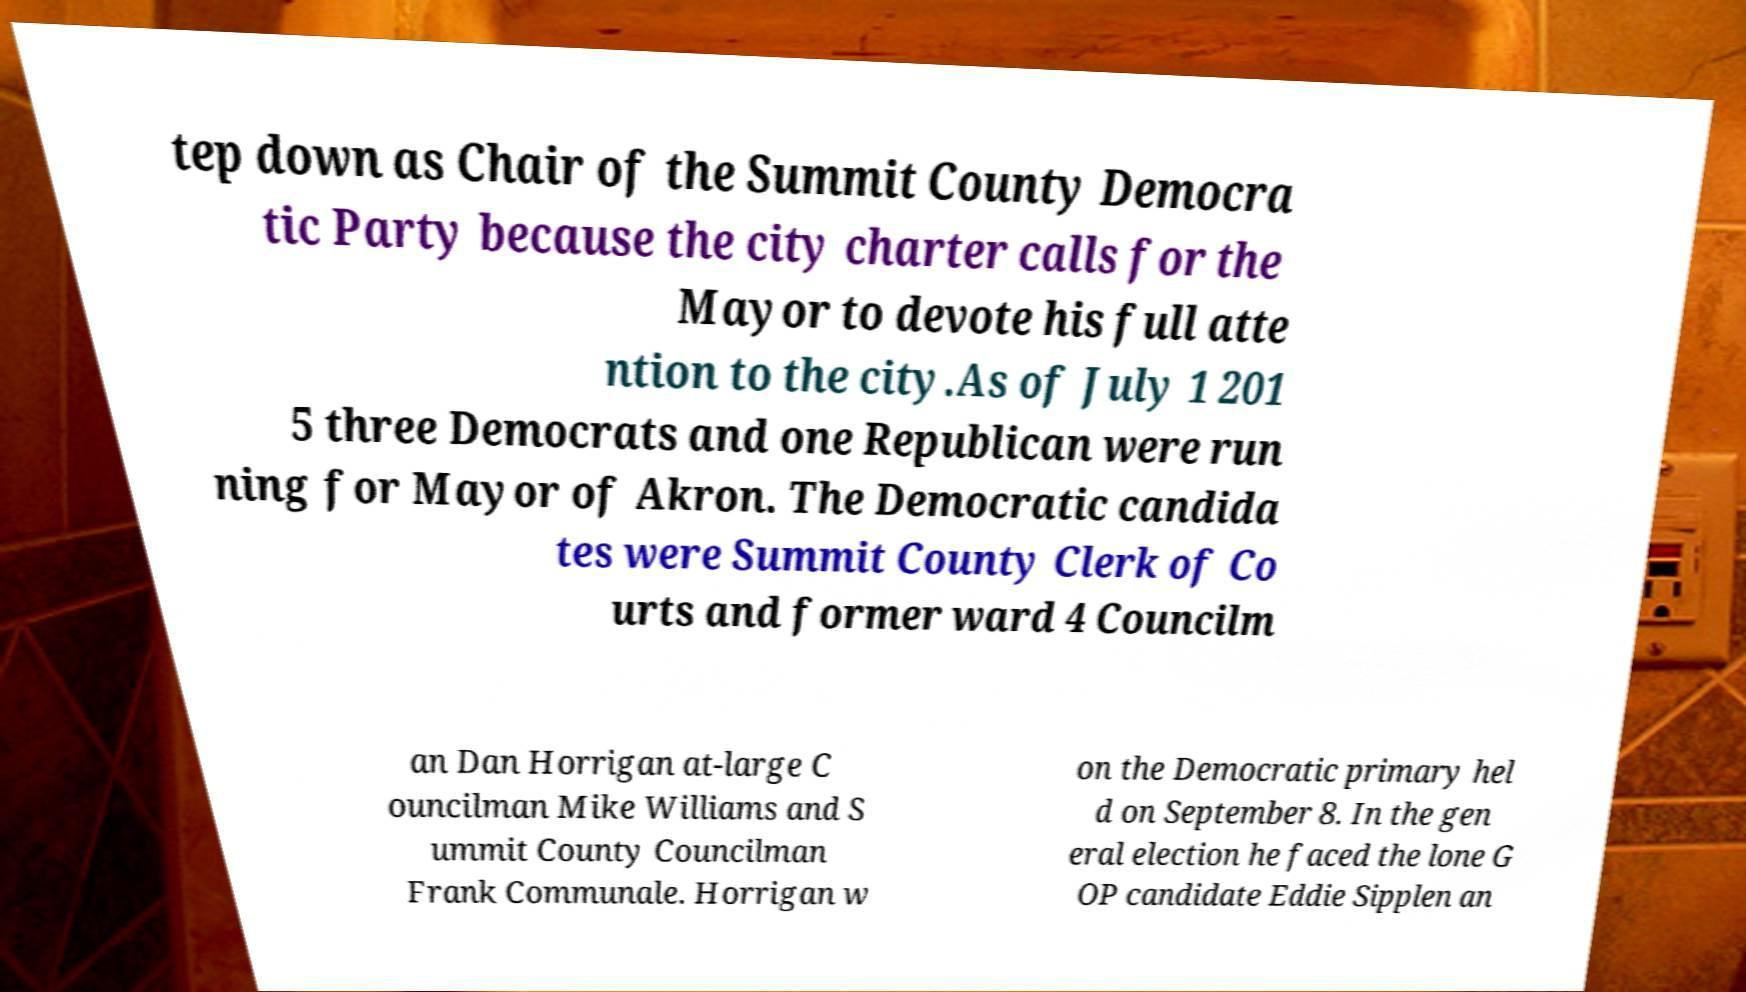Please identify and transcribe the text found in this image. tep down as Chair of the Summit County Democra tic Party because the city charter calls for the Mayor to devote his full atte ntion to the city.As of July 1 201 5 three Democrats and one Republican were run ning for Mayor of Akron. The Democratic candida tes were Summit County Clerk of Co urts and former ward 4 Councilm an Dan Horrigan at-large C ouncilman Mike Williams and S ummit County Councilman Frank Communale. Horrigan w on the Democratic primary hel d on September 8. In the gen eral election he faced the lone G OP candidate Eddie Sipplen an 